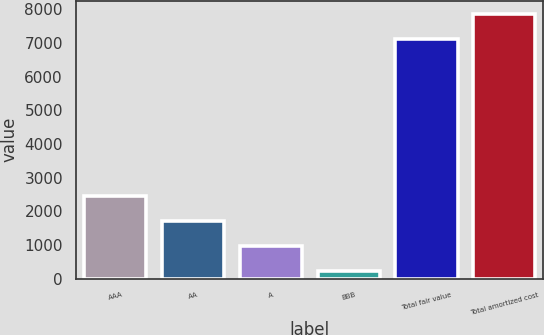<chart> <loc_0><loc_0><loc_500><loc_500><bar_chart><fcel>AAA<fcel>AA<fcel>A<fcel>BBB<fcel>Total fair value<fcel>Total amortized cost<nl><fcel>2452<fcel>1710<fcel>968<fcel>226<fcel>7114<fcel>7856<nl></chart> 